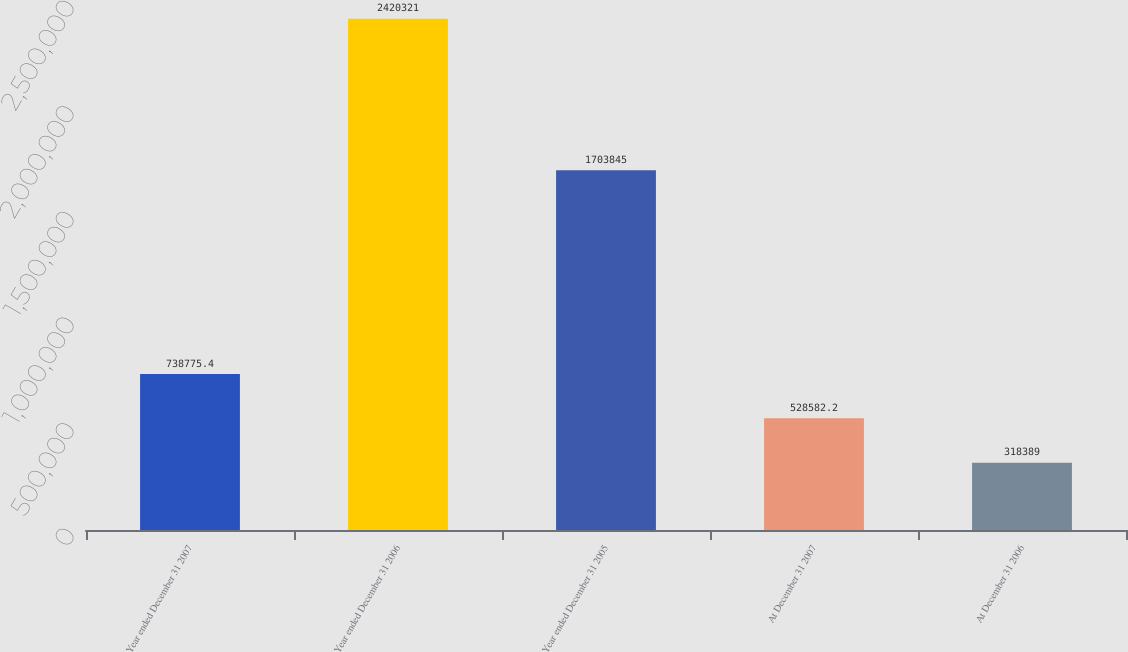<chart> <loc_0><loc_0><loc_500><loc_500><bar_chart><fcel>Year ended December 31 2007<fcel>Year ended December 31 2006<fcel>Year ended December 31 2005<fcel>At December 31 2007<fcel>At December 31 2006<nl><fcel>738775<fcel>2.42032e+06<fcel>1.70384e+06<fcel>528582<fcel>318389<nl></chart> 